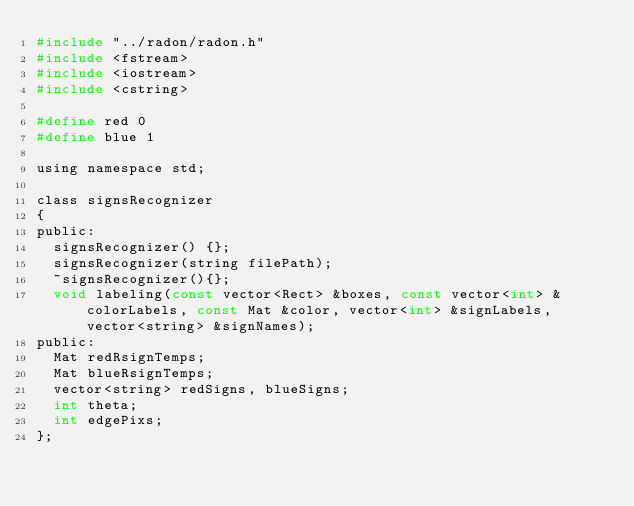<code> <loc_0><loc_0><loc_500><loc_500><_C_>#include "../radon/radon.h"
#include <fstream>
#include <iostream>
#include <cstring>

#define red 0
#define blue 1

using namespace std;

class signsRecognizer
{
public:
	signsRecognizer() {};
	signsRecognizer(string filePath);
	~signsRecognizer(){};
	void labeling(const vector<Rect> &boxes, const vector<int> &colorLabels, const Mat &color, vector<int> &signLabels, vector<string> &signNames);
public:
	Mat redRsignTemps;
	Mat blueRsignTemps;
	vector<string> redSigns, blueSigns;
	int theta;
	int edgePixs;
};
</code> 